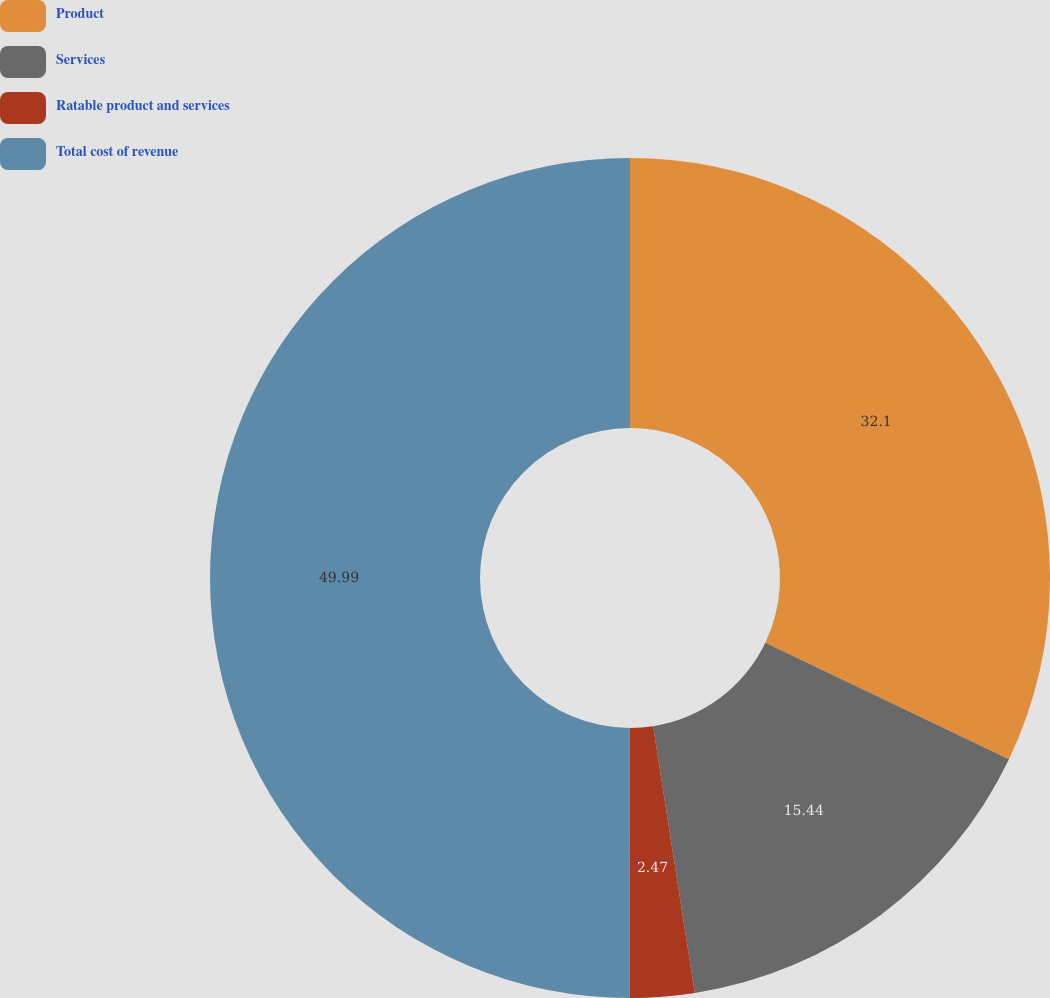<chart> <loc_0><loc_0><loc_500><loc_500><pie_chart><fcel>Product<fcel>Services<fcel>Ratable product and services<fcel>Total cost of revenue<nl><fcel>32.1%<fcel>15.44%<fcel>2.47%<fcel>50.0%<nl></chart> 